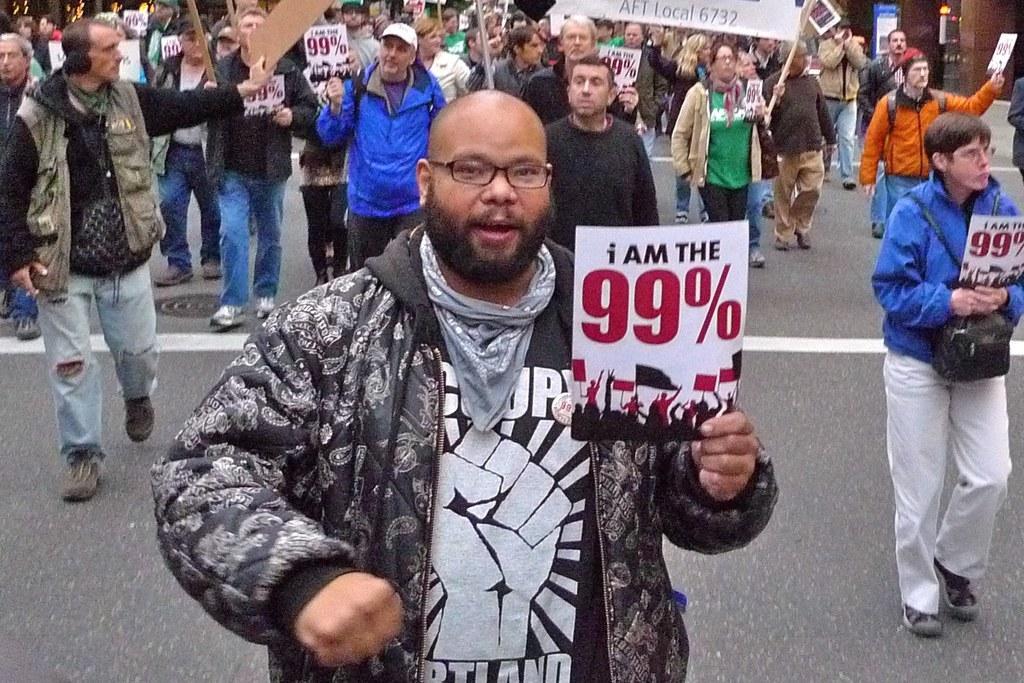What is the main subject of the image? The main subject of the image is a crowd. What are some people in the crowd wearing? Some people in the crowd are wearing caps. What are some people in the crowd holding? Some people in the crowd are holding posters and placards. Where are the people in the crowd walking? The people in the crowd are walking on the road. What type of music can be heard coming from the system in the image? There is no system or music present in the image; it features a crowd of people walking on the road. 